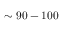<formula> <loc_0><loc_0><loc_500><loc_500>\sim 9 0 - 1 0 0</formula> 